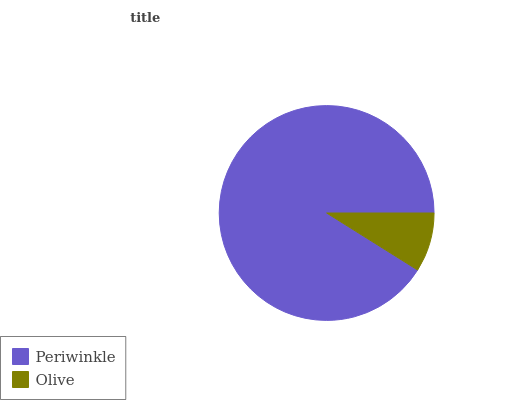Is Olive the minimum?
Answer yes or no. Yes. Is Periwinkle the maximum?
Answer yes or no. Yes. Is Olive the maximum?
Answer yes or no. No. Is Periwinkle greater than Olive?
Answer yes or no. Yes. Is Olive less than Periwinkle?
Answer yes or no. Yes. Is Olive greater than Periwinkle?
Answer yes or no. No. Is Periwinkle less than Olive?
Answer yes or no. No. Is Periwinkle the high median?
Answer yes or no. Yes. Is Olive the low median?
Answer yes or no. Yes. Is Olive the high median?
Answer yes or no. No. Is Periwinkle the low median?
Answer yes or no. No. 